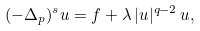Convert formula to latex. <formula><loc_0><loc_0><loc_500><loc_500>( - \Delta _ { p } ) ^ { s } u = f + \lambda \, | u | ^ { q - 2 } \, u ,</formula> 